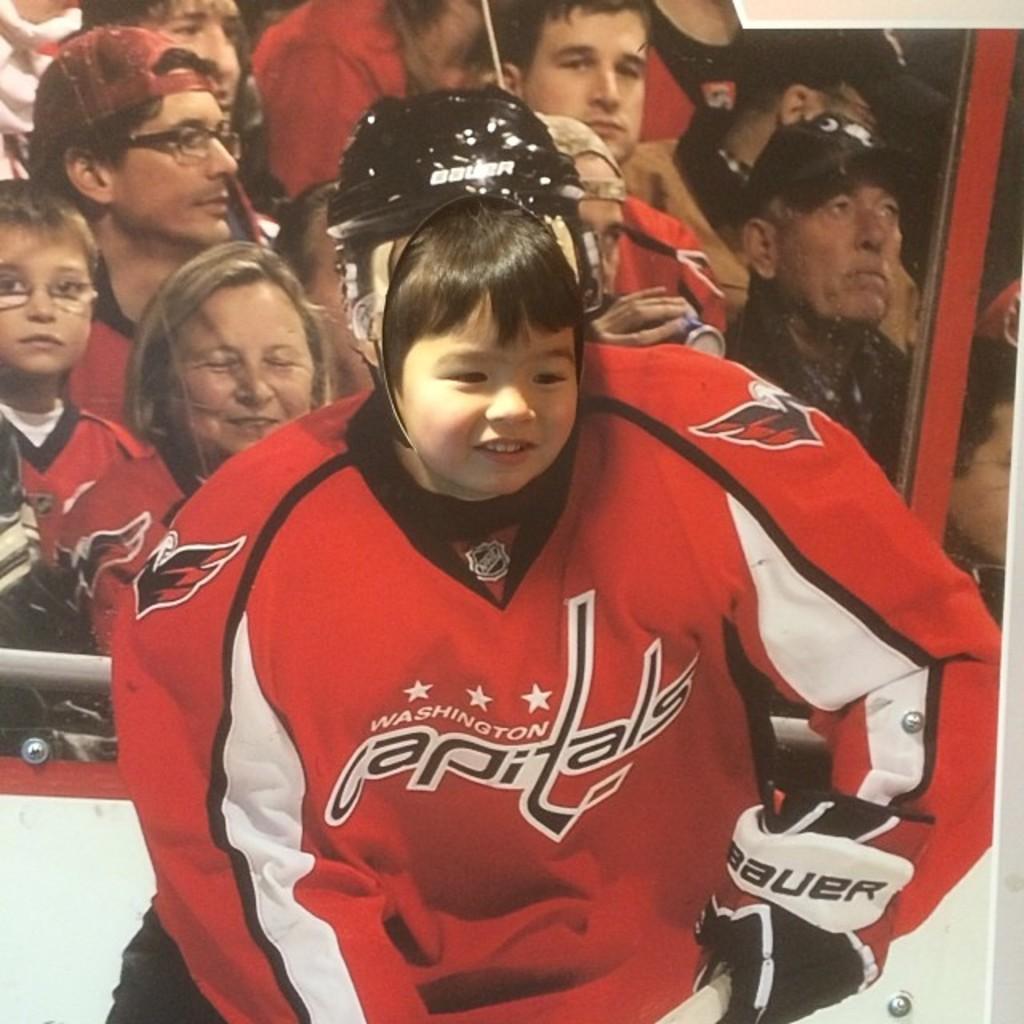What is the team name?
Provide a succinct answer. Capitals. 